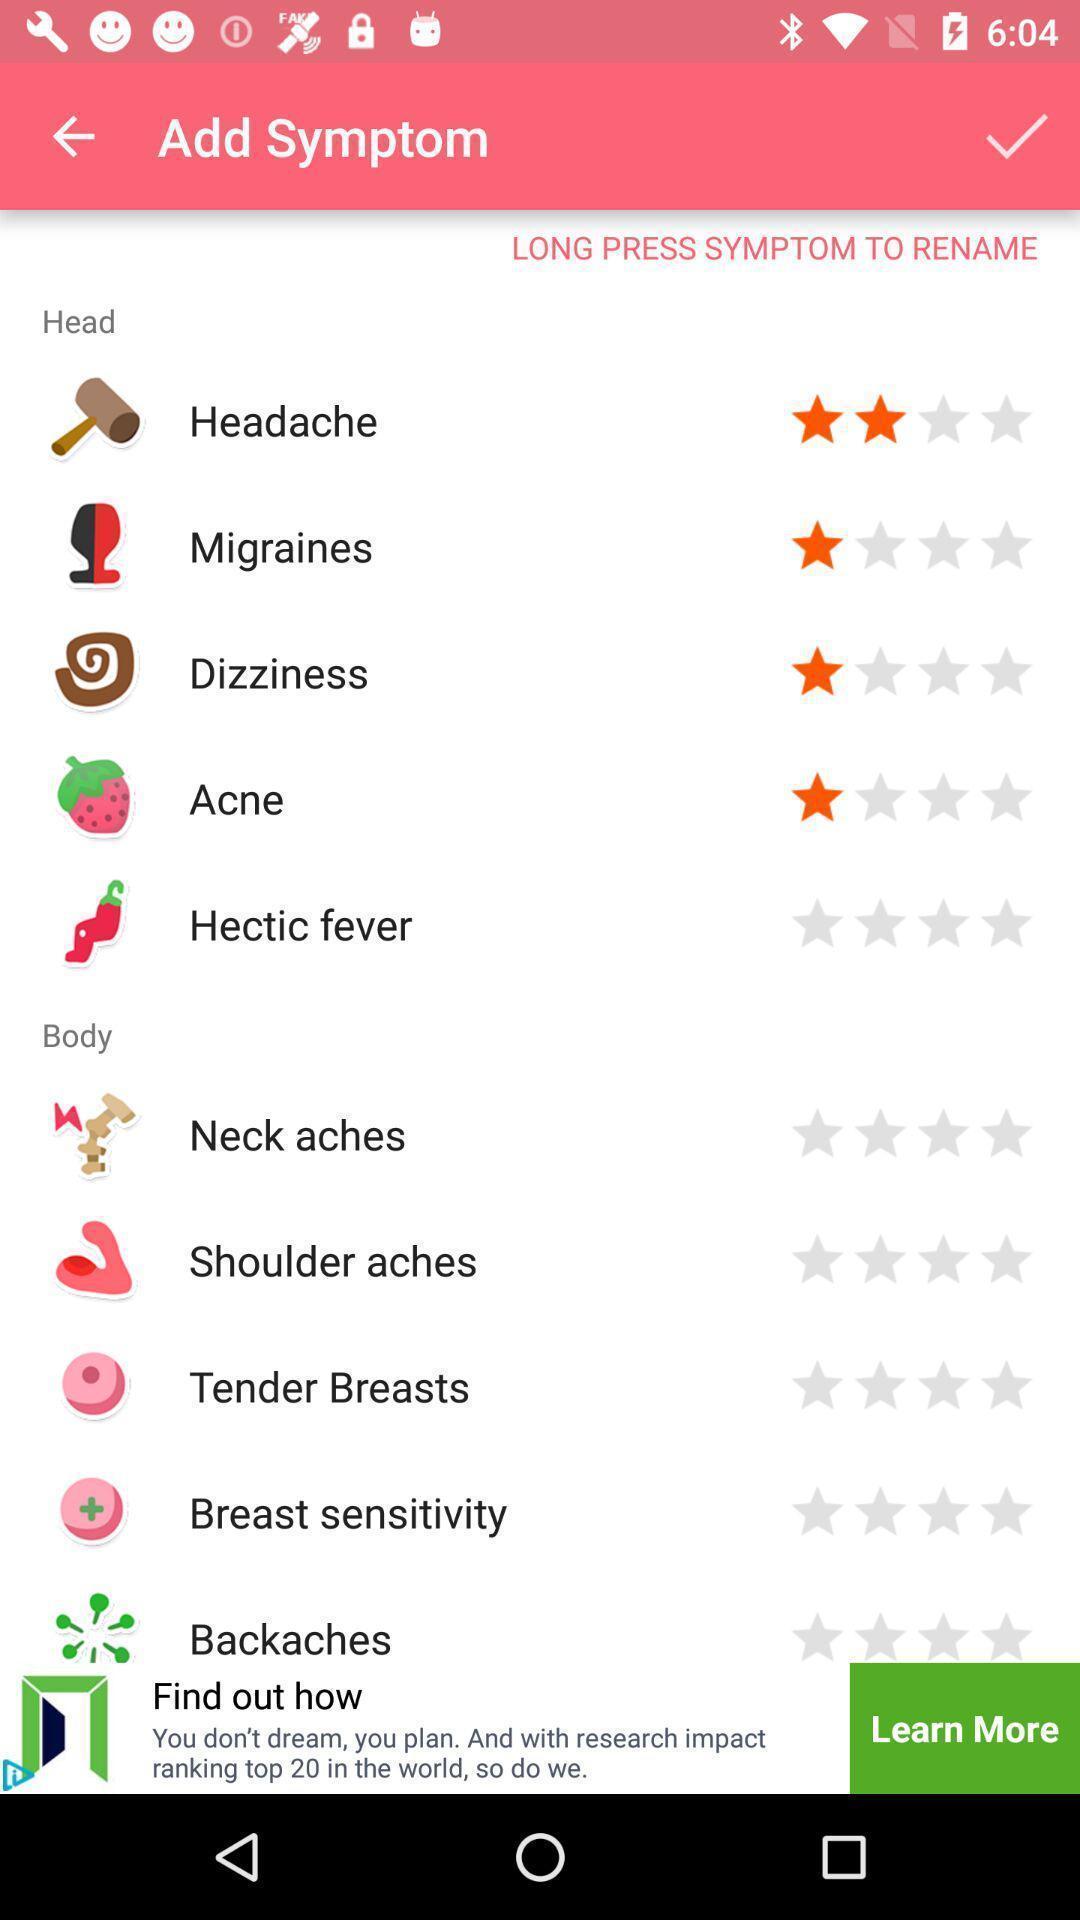Describe the key features of this screenshot. Page displaying list of symptoms in the app. 